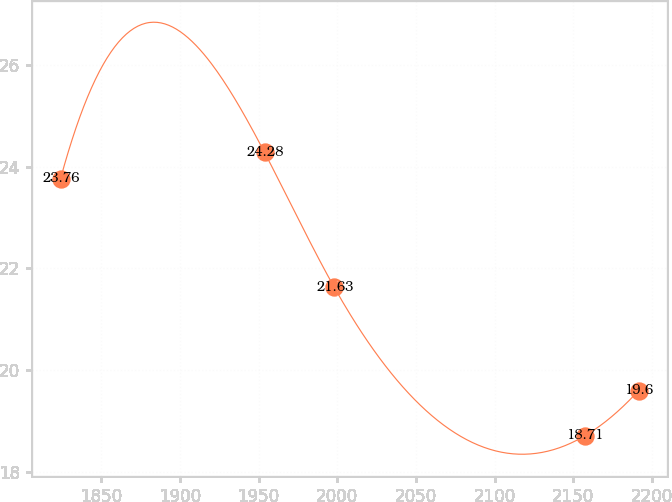<chart> <loc_0><loc_0><loc_500><loc_500><line_chart><ecel><fcel>Unnamed: 1<nl><fcel>1824.01<fcel>23.76<nl><fcel>1953.71<fcel>24.28<nl><fcel>1998.04<fcel>21.63<nl><fcel>2157.31<fcel>18.71<nl><fcel>2191.56<fcel>19.6<nl></chart> 